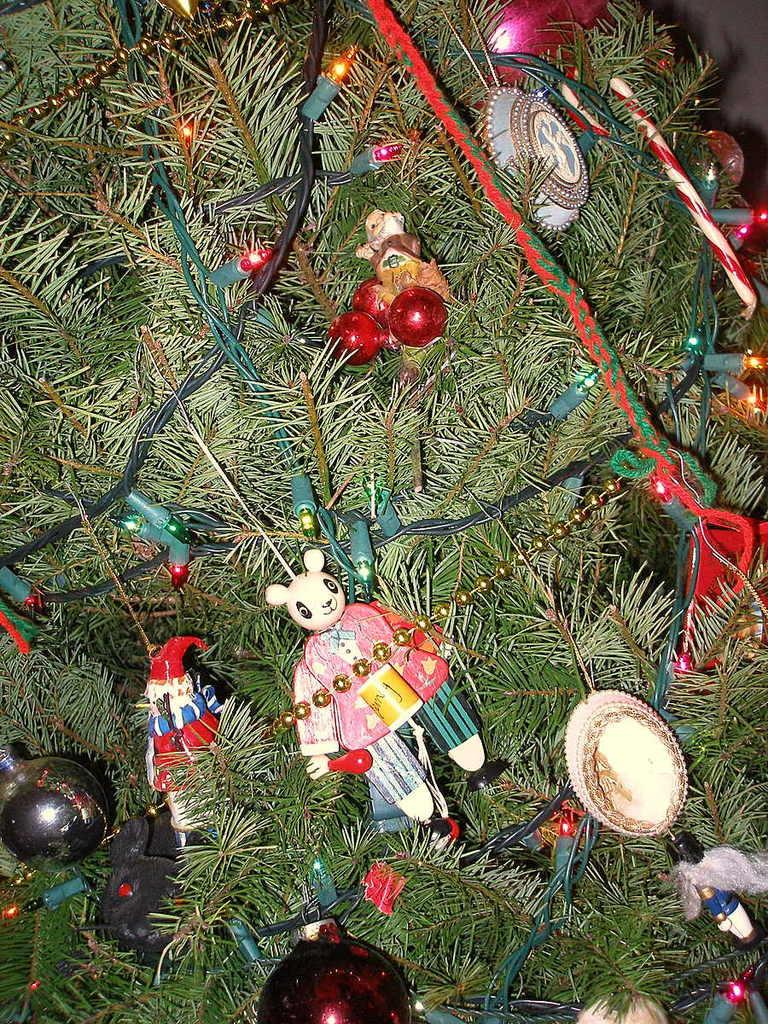What type of tree is featured in the image? There is a Christmas tree in the image. What color is the Christmas tree? The Christmas tree is green. Are there any decorations on the Christmas tree? Yes, there are lights on the Christmas tree. What other items can be seen in the image besides the Christmas tree? There are multi-color toys in the image. Can you see any hooks on the Christmas tree in the image? There is no mention of hooks on the Christmas tree in the provided facts, so we cannot determine if any are present. 